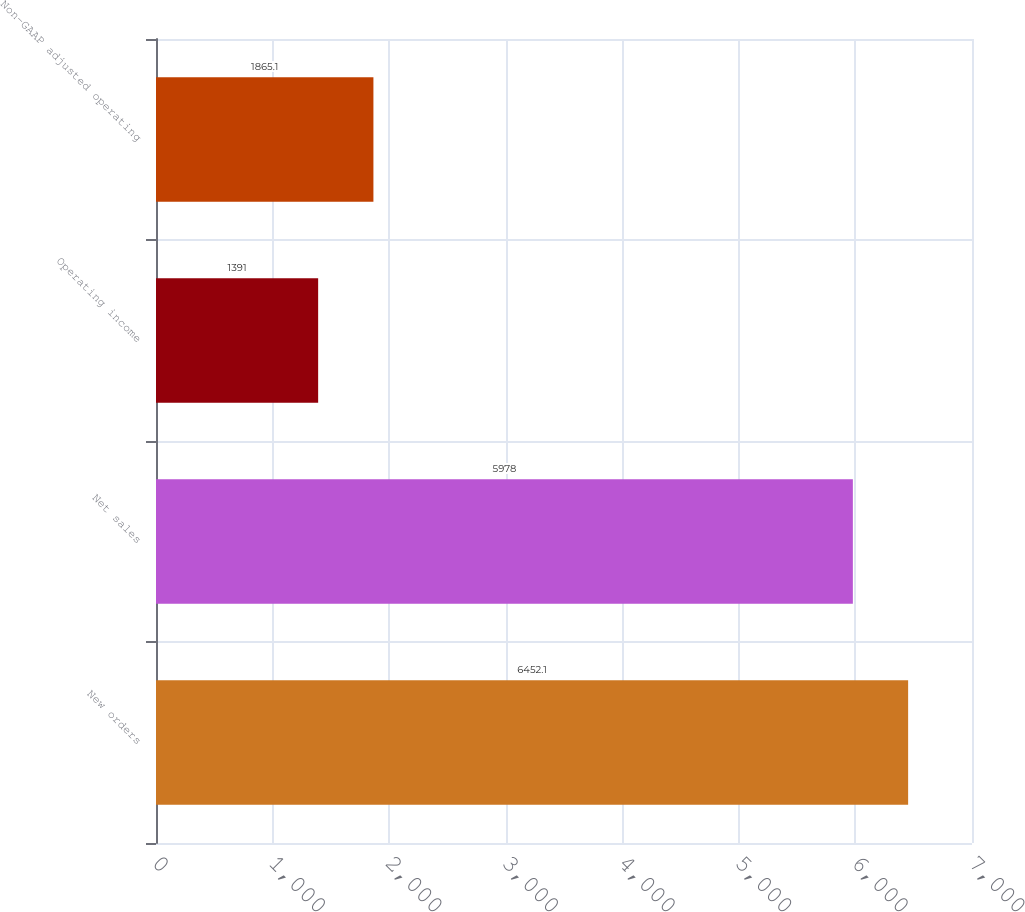Convert chart to OTSL. <chart><loc_0><loc_0><loc_500><loc_500><bar_chart><fcel>New orders<fcel>Net sales<fcel>Operating income<fcel>Non-GAAP adjusted operating<nl><fcel>6452.1<fcel>5978<fcel>1391<fcel>1865.1<nl></chart> 